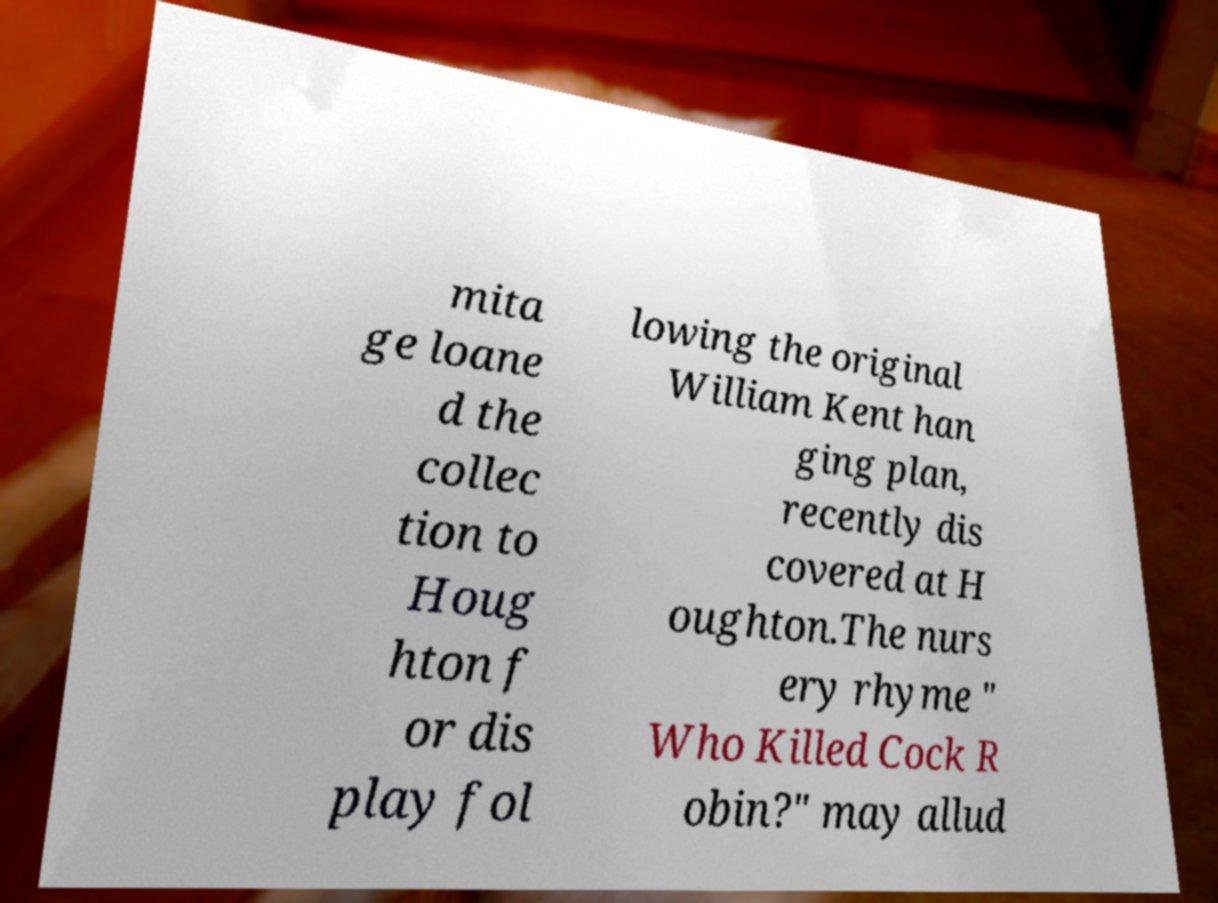What messages or text are displayed in this image? I need them in a readable, typed format. mita ge loane d the collec tion to Houg hton f or dis play fol lowing the original William Kent han ging plan, recently dis covered at H oughton.The nurs ery rhyme " Who Killed Cock R obin?" may allud 